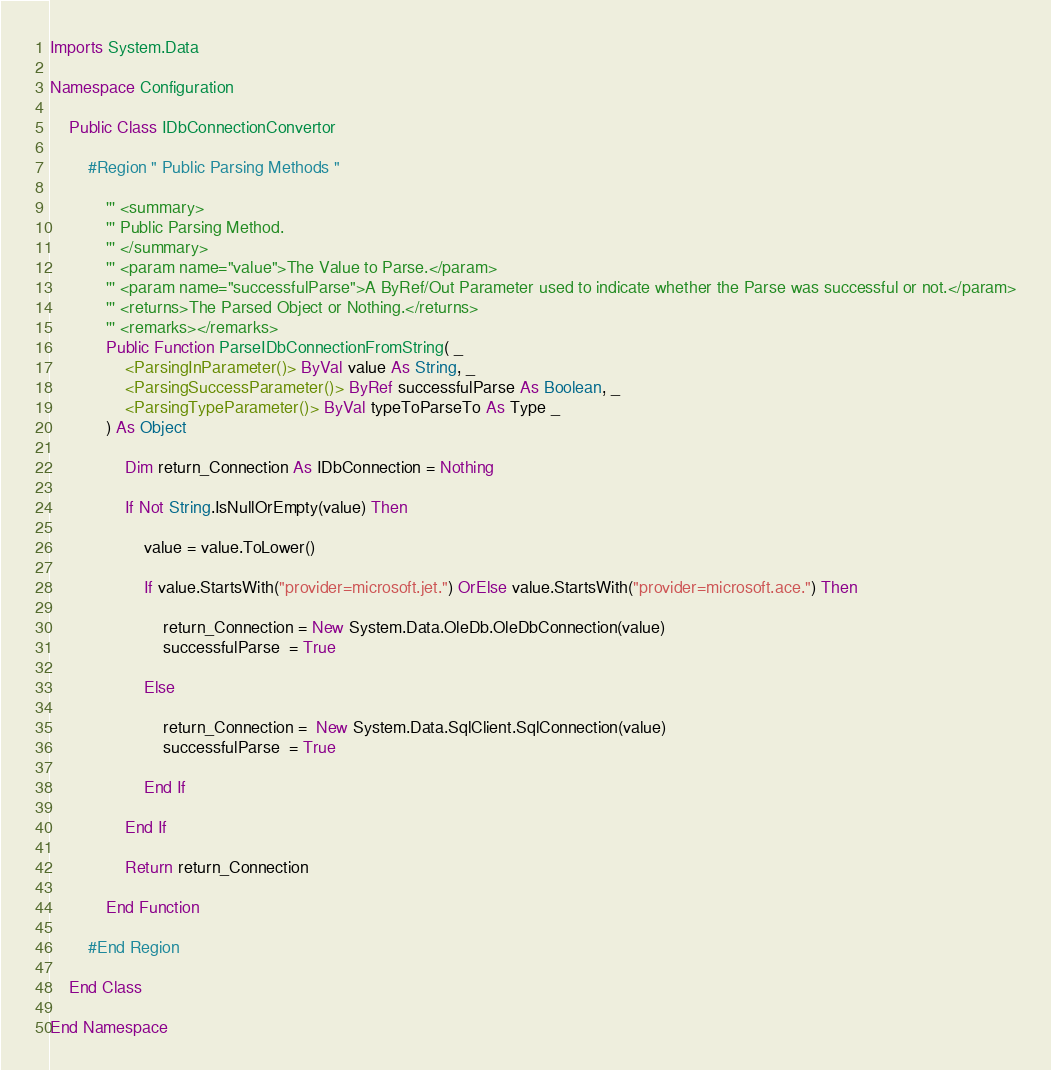<code> <loc_0><loc_0><loc_500><loc_500><_VisualBasic_>Imports System.Data

Namespace Configuration

	Public Class IDbConnectionConvertor

		#Region " Public Parsing Methods "

			''' <summary>
			''' Public Parsing Method.
			''' </summary>
			''' <param name="value">The Value to Parse.</param>
			''' <param name="successfulParse">A ByRef/Out Parameter used to indicate whether the Parse was successful or not.</param>
			''' <returns>The Parsed Object or Nothing.</returns>
			''' <remarks></remarks>
			Public Function ParseIDbConnectionFromString( _
				<ParsingInParameter()> ByVal value As String, _
				<ParsingSuccessParameter()> ByRef successfulParse As Boolean, _
				<ParsingTypeParameter()> ByVal typeToParseTo As Type _
			) As Object

				Dim return_Connection As IDbConnection = Nothing

				If Not String.IsNullOrEmpty(value) Then

					value = value.ToLower()

					If value.StartsWith("provider=microsoft.jet.") OrElse value.StartsWith("provider=microsoft.ace.") Then

						return_Connection = New System.Data.OleDb.OleDbConnection(value)
						successfulParse  = True

					Else

						return_Connection =  New System.Data.SqlClient.SqlConnection(value)
						successfulParse  = True

					End If

				End If

				Return return_Connection

			End Function

		#End Region

	End Class

End Namespace
</code> 